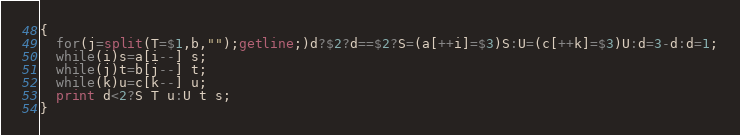Convert code to text. <code><loc_0><loc_0><loc_500><loc_500><_Awk_>{
  for(j=split(T=$1,b,"");getline;)d?$2?d==$2?S=(a[++i]=$3)S:U=(c[++k]=$3)U:d=3-d:d=1;
  while(i)s=a[i--] s;
  while(j)t=b[j--] t;
  while(k)u=c[k--] u;
  print d<2?S T u:U t s;
}</code> 